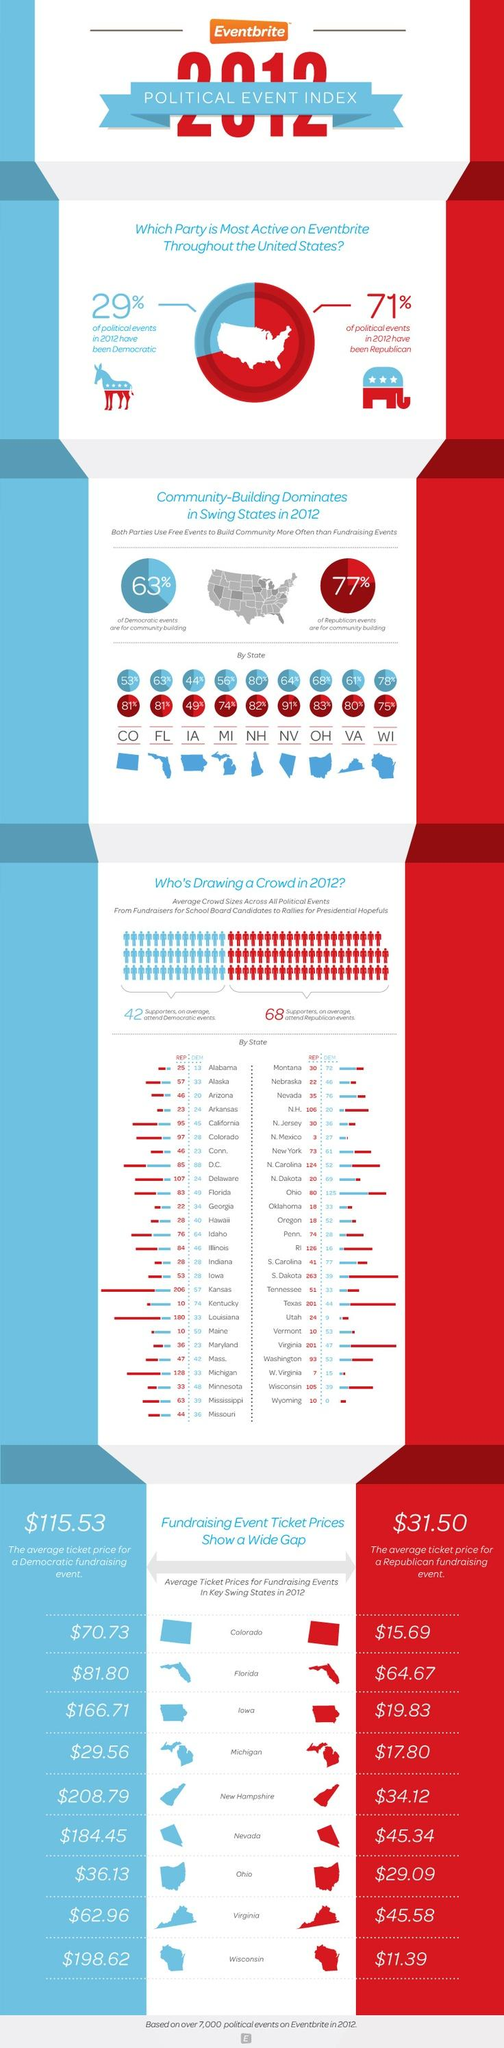Highlight a few significant elements in this photo. According to Niveda, a Republican platform, 91% of Republican events are used for community building. The state with the highest average ticket price for Democratic fundraising events was New Hampshire, where the average ticket price was $208.79. Red is the color that is used to represent the Republicans. The Republican political group is represented by the elephant. In 2012, a significant majority of political events were held by the Republican Party. 